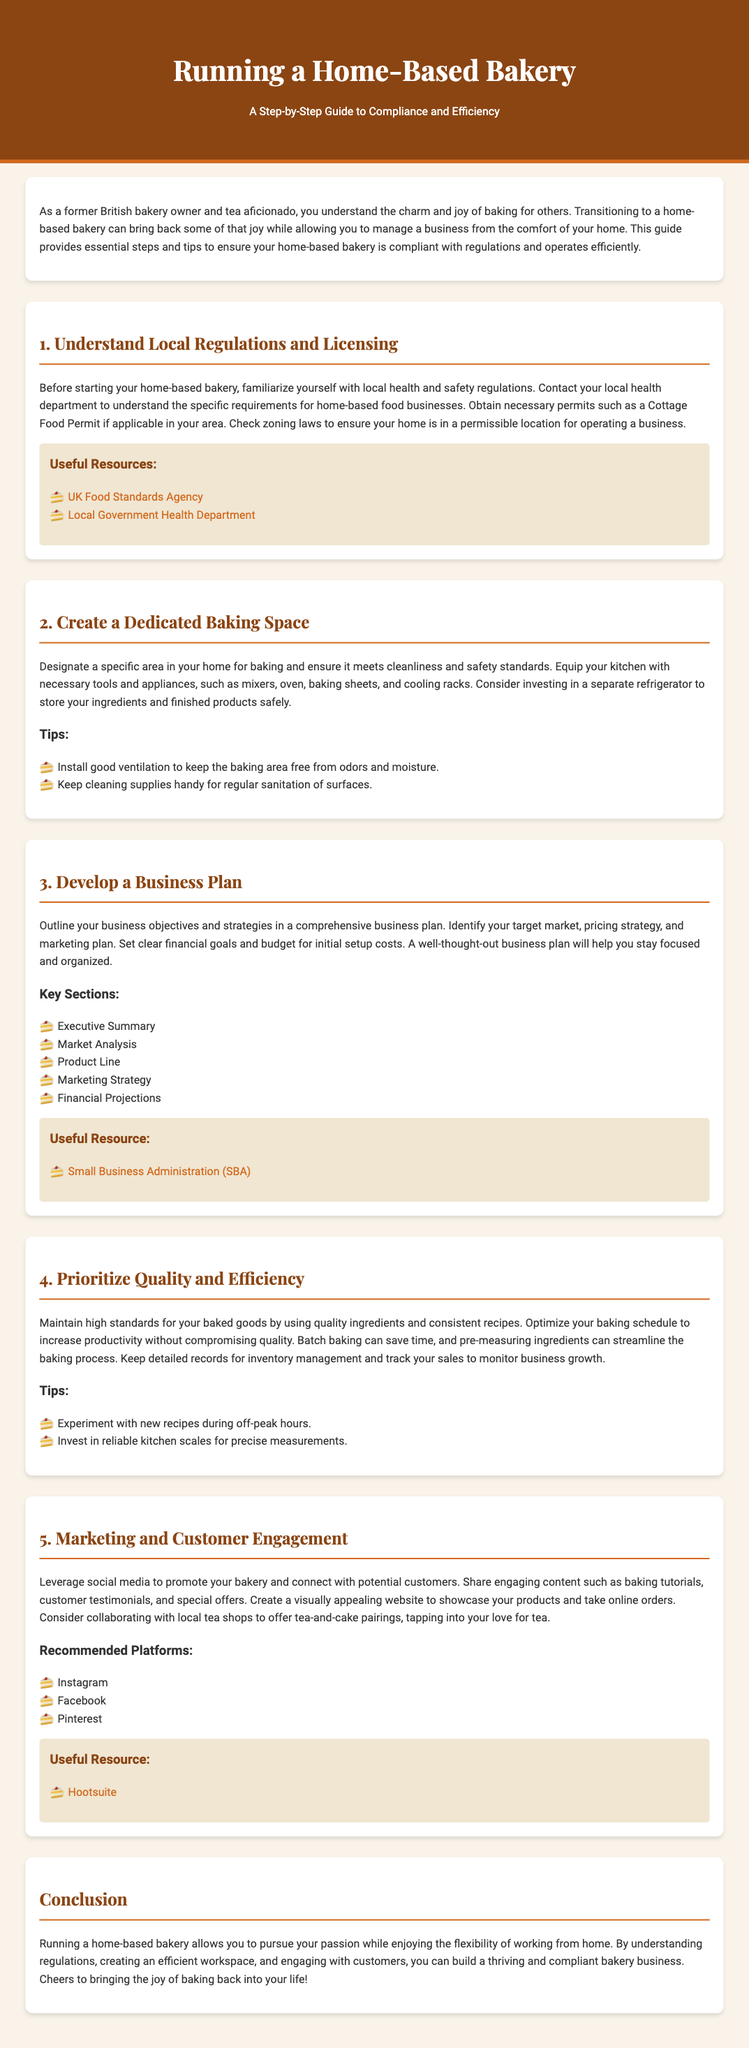What is the title of the guide? The title of the guide provides the main theme of the document, which is centered around operating a home-based bakery.
Answer: Running a Home-Based Bakery What is the first step in running a home-based bakery? The first step outlines the importance of understanding local regulations and licensing to ensure compliance.
Answer: Understand Local Regulations and Licensing What type of permit is mentioned as necessary? This permit is specific to individuals operating food businesses from home and is necessary for compliance with local regulations.
Answer: Cottage Food Permit What resource is recommended for writing a business plan? The resource guides users on how to create a comprehensive business plan for their bakery venture.
Answer: Small Business Administration (SBA) What should be prioritized to maintain high standards in baking? The guide emphasizes the importance of quality ingredients and consistent recipes in maintaining baking standards.
Answer: Quality and Efficiency Which social media platform is recommended for marketing? This platform allows bakers to visually showcase their products and connect with customers, enhancing their marketing efforts.
Answer: Instagram How many key sections are suggested for the business plan? This number indicates the comprehensive approach to creating a business plan, ensuring important aspects are covered.
Answer: Five What type of area should be designated for baking? This specification is crucial for maintaining safety and cleanliness while running a home-based bakery.
Answer: Dedicated Baking Space What is the primary benefit highlighted about running a home-based bakery? This benefit reflects the flexibility and personal fulfillment derived from managing the business from home.
Answer: Flexibility 